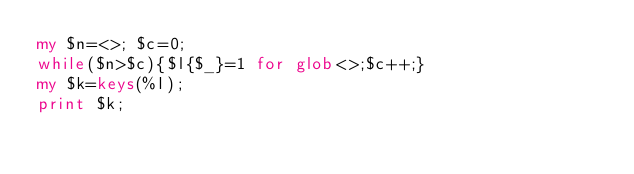Convert code to text. <code><loc_0><loc_0><loc_500><loc_500><_Perl_>my $n=<>; $c=0;
while($n>$c){$l{$_}=1 for glob<>;$c++;}
my $k=keys(%l);
print $k;</code> 